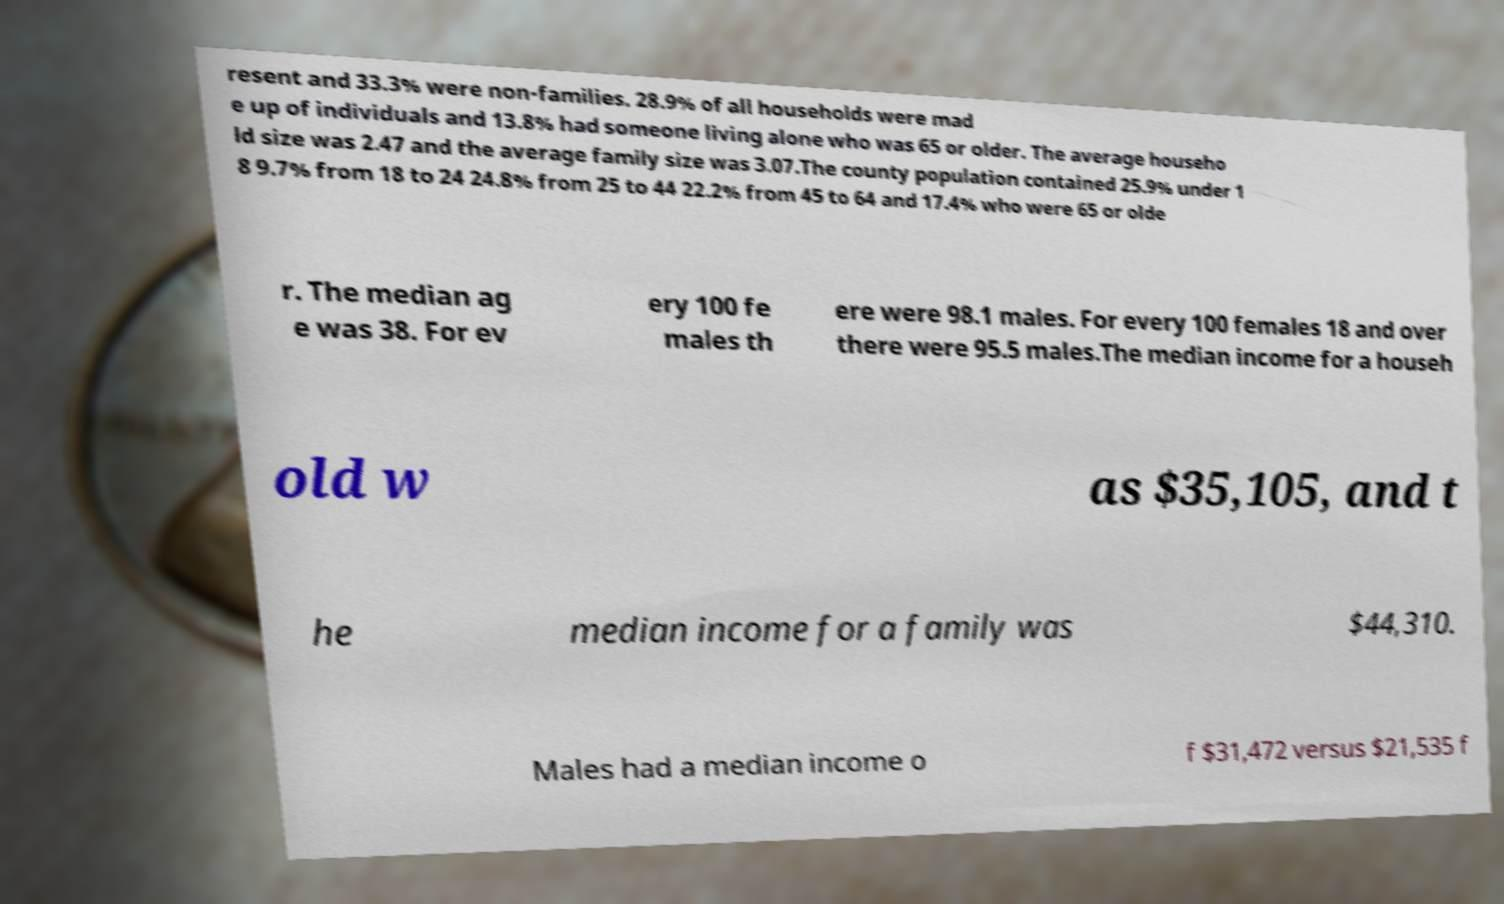What messages or text are displayed in this image? I need them in a readable, typed format. resent and 33.3% were non-families. 28.9% of all households were mad e up of individuals and 13.8% had someone living alone who was 65 or older. The average househo ld size was 2.47 and the average family size was 3.07.The county population contained 25.9% under 1 8 9.7% from 18 to 24 24.8% from 25 to 44 22.2% from 45 to 64 and 17.4% who were 65 or olde r. The median ag e was 38. For ev ery 100 fe males th ere were 98.1 males. For every 100 females 18 and over there were 95.5 males.The median income for a househ old w as $35,105, and t he median income for a family was $44,310. Males had a median income o f $31,472 versus $21,535 f 